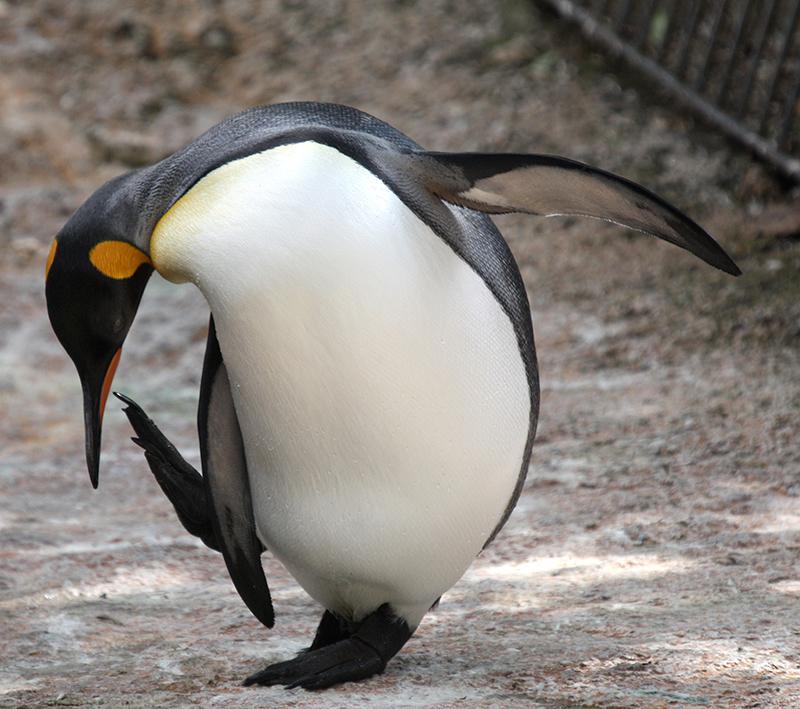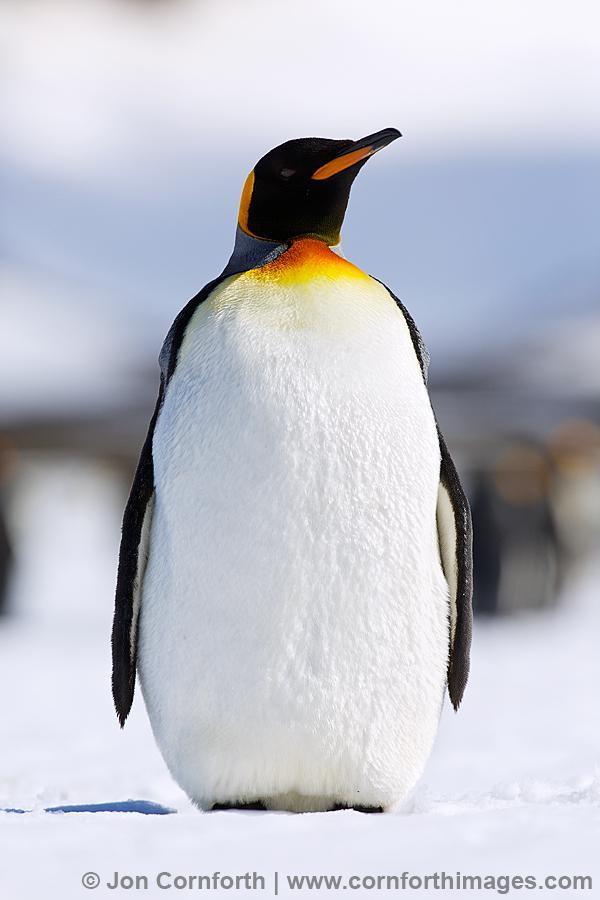The first image is the image on the left, the second image is the image on the right. Given the left and right images, does the statement "There are at most 4 penguins total in both images." hold true? Answer yes or no. Yes. The first image is the image on the left, the second image is the image on the right. Examine the images to the left and right. Is the description "There are no more than two animals in the image on the right." accurate? Answer yes or no. Yes. 